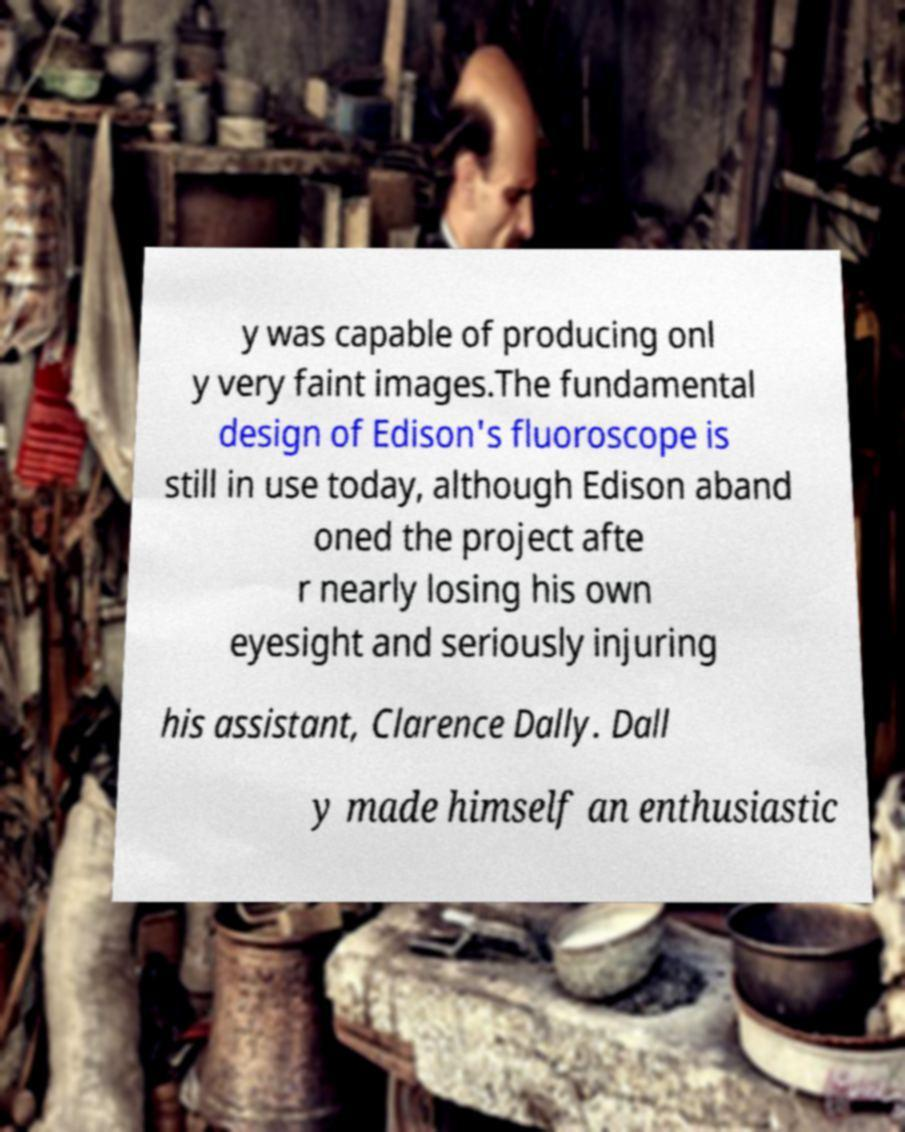Can you accurately transcribe the text from the provided image for me? y was capable of producing onl y very faint images.The fundamental design of Edison's fluoroscope is still in use today, although Edison aband oned the project afte r nearly losing his own eyesight and seriously injuring his assistant, Clarence Dally. Dall y made himself an enthusiastic 